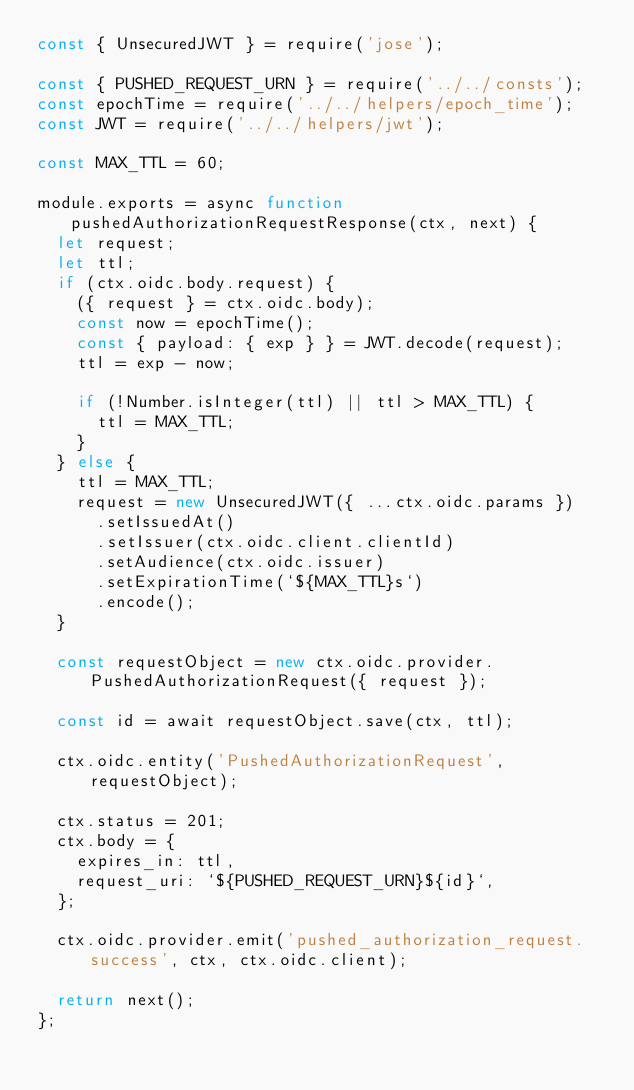Convert code to text. <code><loc_0><loc_0><loc_500><loc_500><_JavaScript_>const { UnsecuredJWT } = require('jose');

const { PUSHED_REQUEST_URN } = require('../../consts');
const epochTime = require('../../helpers/epoch_time');
const JWT = require('../../helpers/jwt');

const MAX_TTL = 60;

module.exports = async function pushedAuthorizationRequestResponse(ctx, next) {
  let request;
  let ttl;
  if (ctx.oidc.body.request) {
    ({ request } = ctx.oidc.body);
    const now = epochTime();
    const { payload: { exp } } = JWT.decode(request);
    ttl = exp - now;

    if (!Number.isInteger(ttl) || ttl > MAX_TTL) {
      ttl = MAX_TTL;
    }
  } else {
    ttl = MAX_TTL;
    request = new UnsecuredJWT({ ...ctx.oidc.params })
      .setIssuedAt()
      .setIssuer(ctx.oidc.client.clientId)
      .setAudience(ctx.oidc.issuer)
      .setExpirationTime(`${MAX_TTL}s`)
      .encode();
  }

  const requestObject = new ctx.oidc.provider.PushedAuthorizationRequest({ request });

  const id = await requestObject.save(ctx, ttl);

  ctx.oidc.entity('PushedAuthorizationRequest', requestObject);

  ctx.status = 201;
  ctx.body = {
    expires_in: ttl,
    request_uri: `${PUSHED_REQUEST_URN}${id}`,
  };

  ctx.oidc.provider.emit('pushed_authorization_request.success', ctx, ctx.oidc.client);

  return next();
};
</code> 